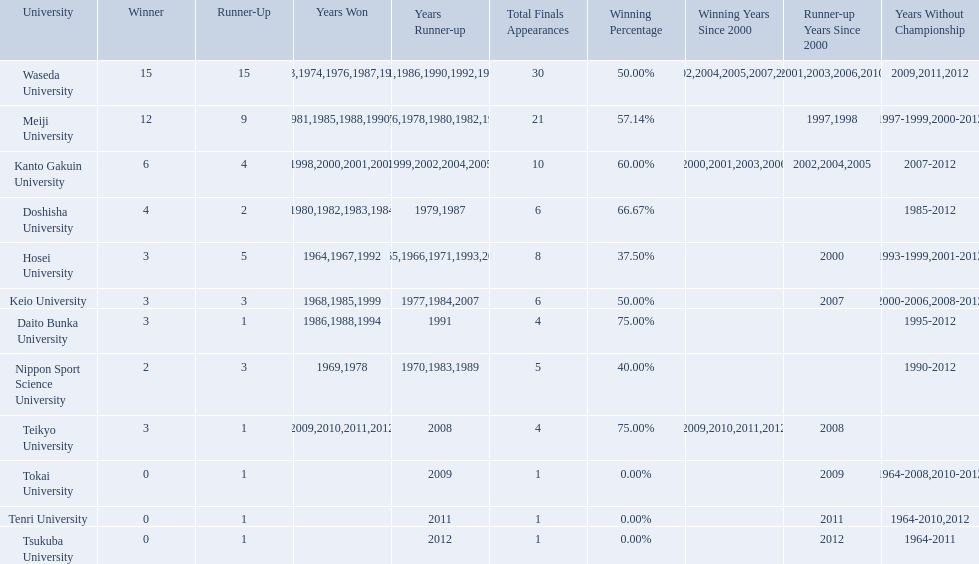What are all of the universities? Waseda University, Meiji University, Kanto Gakuin University, Doshisha University, Hosei University, Keio University, Daito Bunka University, Nippon Sport Science University, Teikyo University, Tokai University, Tenri University, Tsukuba University. And their scores? 15, 12, 6, 4, 3, 3, 3, 2, 3, 0, 0, 0. Which university scored won the most? Waseda University. Which university had 6 wins? Kanto Gakuin University. Which university had 12 wins? Meiji University. Which university had more than 12 wins? Waseda University. 